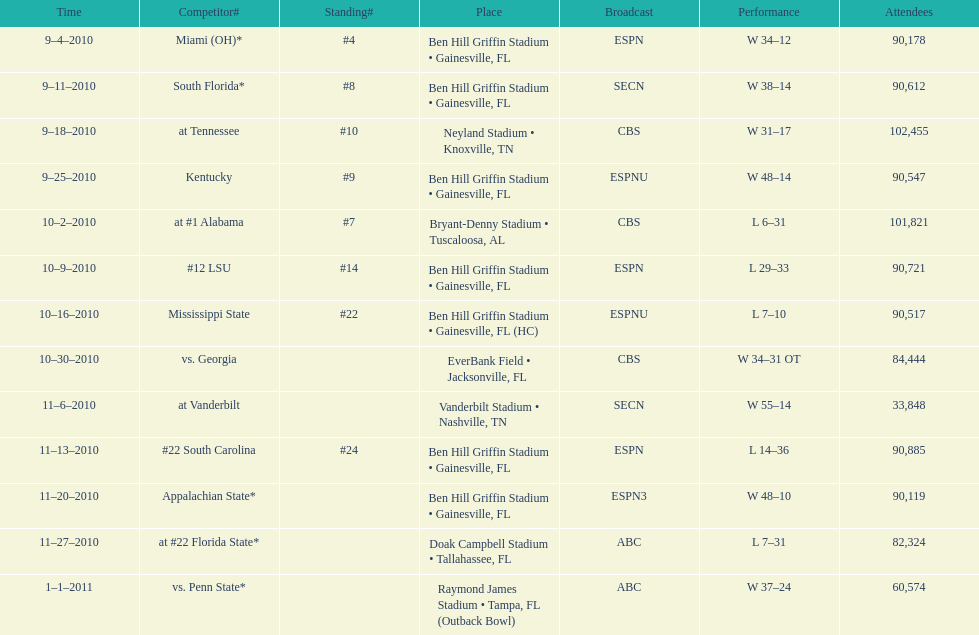What tv network showed the largest number of games during the 2010/2011 season? ESPN. Would you mind parsing the complete table? {'header': ['Time', 'Competitor#', 'Standing#', 'Place', 'Broadcast', 'Performance', 'Attendees'], 'rows': [['9–4–2010', 'Miami (OH)*', '#4', 'Ben Hill Griffin Stadium • Gainesville, FL', 'ESPN', 'W\xa034–12', '90,178'], ['9–11–2010', 'South Florida*', '#8', 'Ben Hill Griffin Stadium • Gainesville, FL', 'SECN', 'W\xa038–14', '90,612'], ['9–18–2010', 'at\xa0Tennessee', '#10', 'Neyland Stadium • Knoxville, TN', 'CBS', 'W\xa031–17', '102,455'], ['9–25–2010', 'Kentucky', '#9', 'Ben Hill Griffin Stadium • Gainesville, FL', 'ESPNU', 'W\xa048–14', '90,547'], ['10–2–2010', 'at\xa0#1\xa0Alabama', '#7', 'Bryant-Denny Stadium • Tuscaloosa, AL', 'CBS', 'L\xa06–31', '101,821'], ['10–9–2010', '#12\xa0LSU', '#14', 'Ben Hill Griffin Stadium • Gainesville, FL', 'ESPN', 'L\xa029–33', '90,721'], ['10–16–2010', 'Mississippi State', '#22', 'Ben Hill Griffin Stadium • Gainesville, FL (HC)', 'ESPNU', 'L\xa07–10', '90,517'], ['10–30–2010', 'vs.\xa0Georgia', '', 'EverBank Field • Jacksonville, FL', 'CBS', 'W\xa034–31\xa0OT', '84,444'], ['11–6–2010', 'at\xa0Vanderbilt', '', 'Vanderbilt Stadium • Nashville, TN', 'SECN', 'W\xa055–14', '33,848'], ['11–13–2010', '#22\xa0South Carolina', '#24', 'Ben Hill Griffin Stadium • Gainesville, FL', 'ESPN', 'L\xa014–36', '90,885'], ['11–20–2010', 'Appalachian State*', '', 'Ben Hill Griffin Stadium • Gainesville, FL', 'ESPN3', 'W\xa048–10', '90,119'], ['11–27–2010', 'at\xa0#22\xa0Florida State*', '', 'Doak Campbell Stadium • Tallahassee, FL', 'ABC', 'L\xa07–31', '82,324'], ['1–1–2011', 'vs.\xa0Penn State*', '', 'Raymond James Stadium • Tampa, FL (Outback Bowl)', 'ABC', 'W\xa037–24', '60,574']]} 